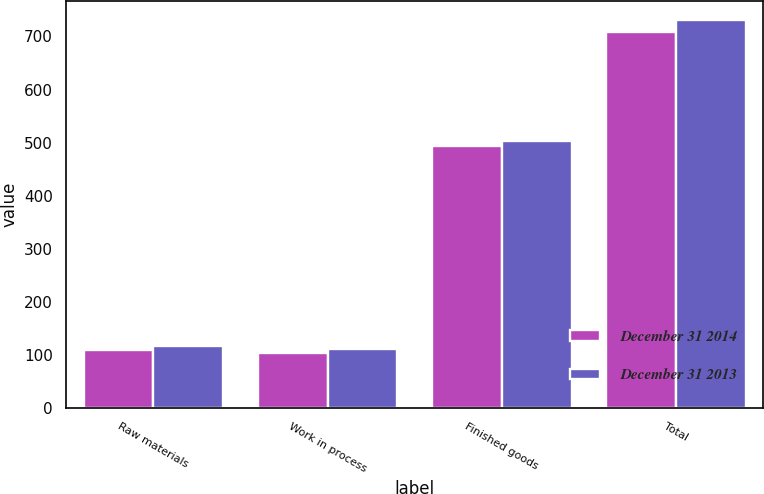<chart> <loc_0><loc_0><loc_500><loc_500><stacked_bar_chart><ecel><fcel>Raw materials<fcel>Work in process<fcel>Finished goods<fcel>Total<nl><fcel>December 31 2014<fcel>108.9<fcel>104<fcel>494.7<fcel>707.6<nl><fcel>December 31 2013<fcel>116.6<fcel>110.9<fcel>502.7<fcel>730.2<nl></chart> 